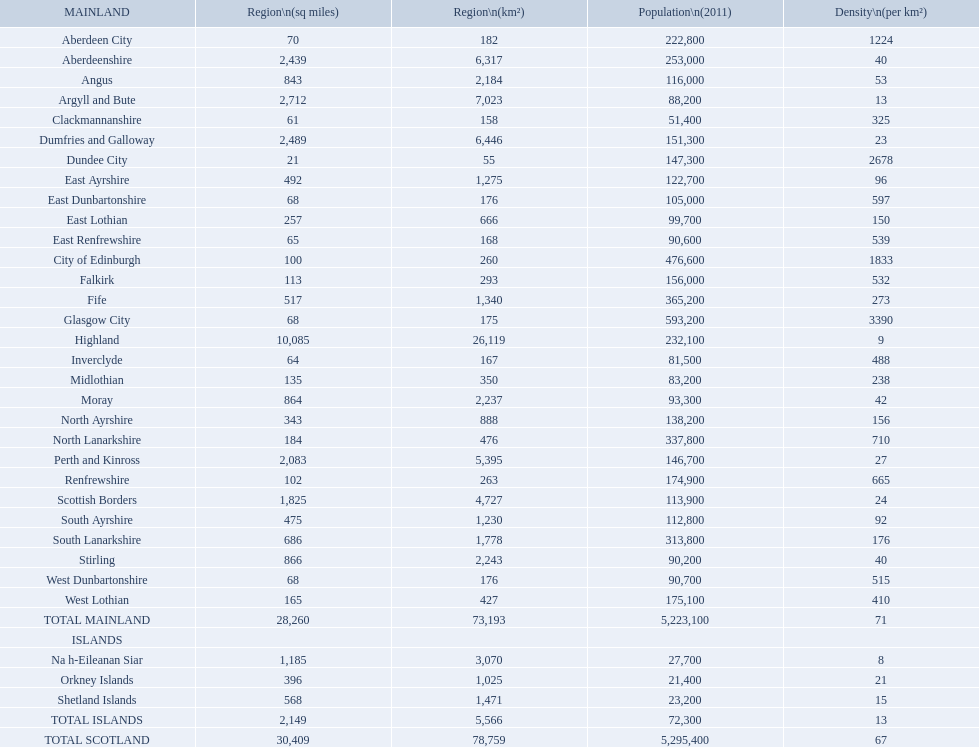Which is the only subdivision to have a greater area than argyll and bute? Highland. 